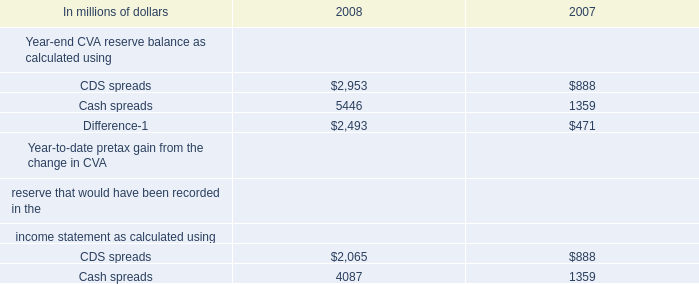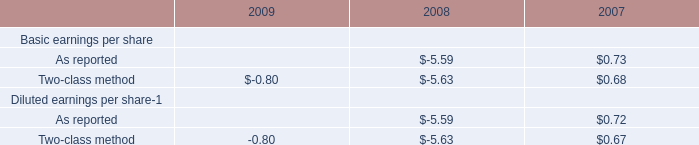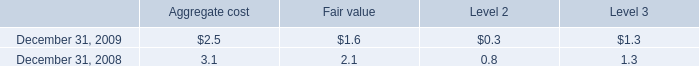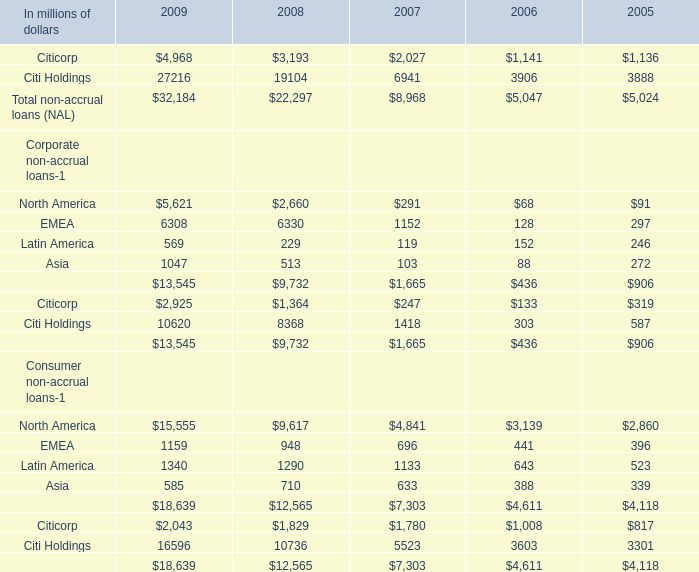What's the growth rate of Total non-accrual loans (NAL) in 2009? 
Computations: ((32184 - 22297) / 22297)
Answer: 0.44342. 